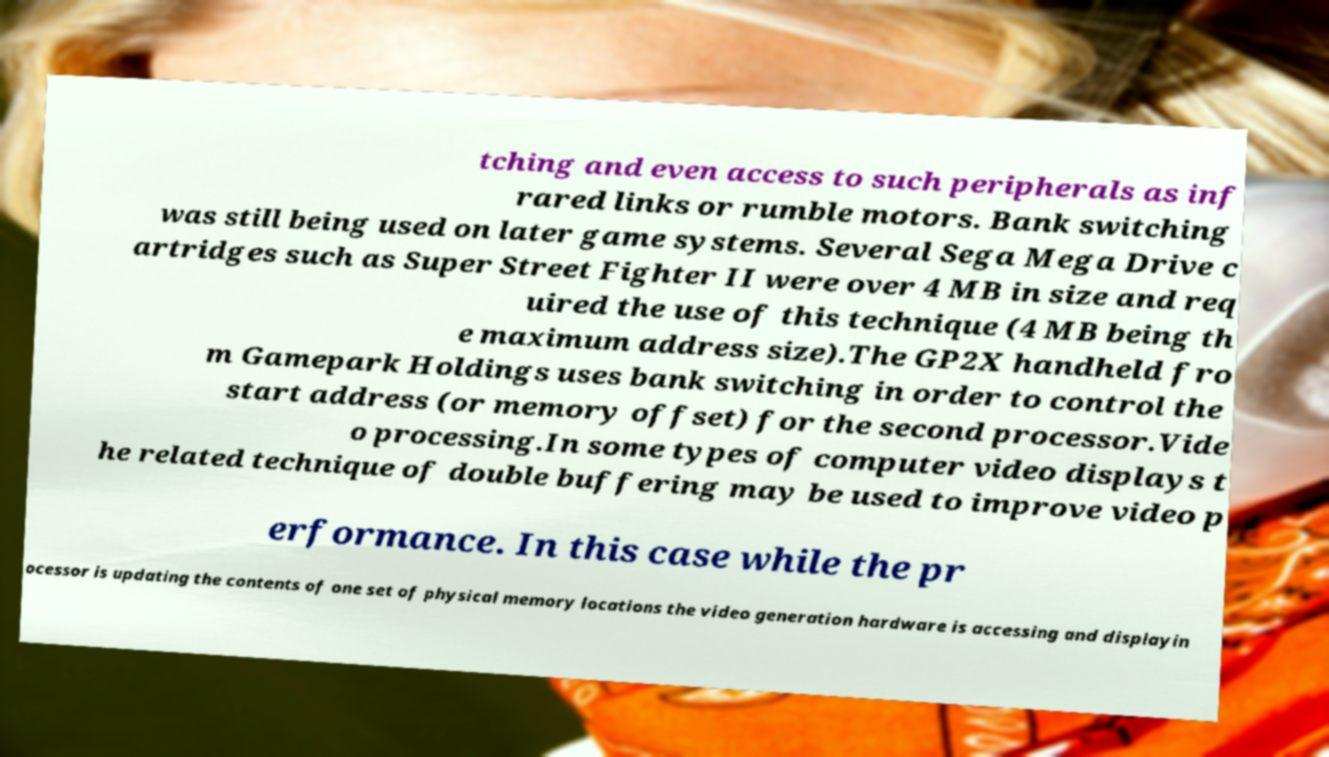Please identify and transcribe the text found in this image. tching and even access to such peripherals as inf rared links or rumble motors. Bank switching was still being used on later game systems. Several Sega Mega Drive c artridges such as Super Street Fighter II were over 4 MB in size and req uired the use of this technique (4 MB being th e maximum address size).The GP2X handheld fro m Gamepark Holdings uses bank switching in order to control the start address (or memory offset) for the second processor.Vide o processing.In some types of computer video displays t he related technique of double buffering may be used to improve video p erformance. In this case while the pr ocessor is updating the contents of one set of physical memory locations the video generation hardware is accessing and displayin 